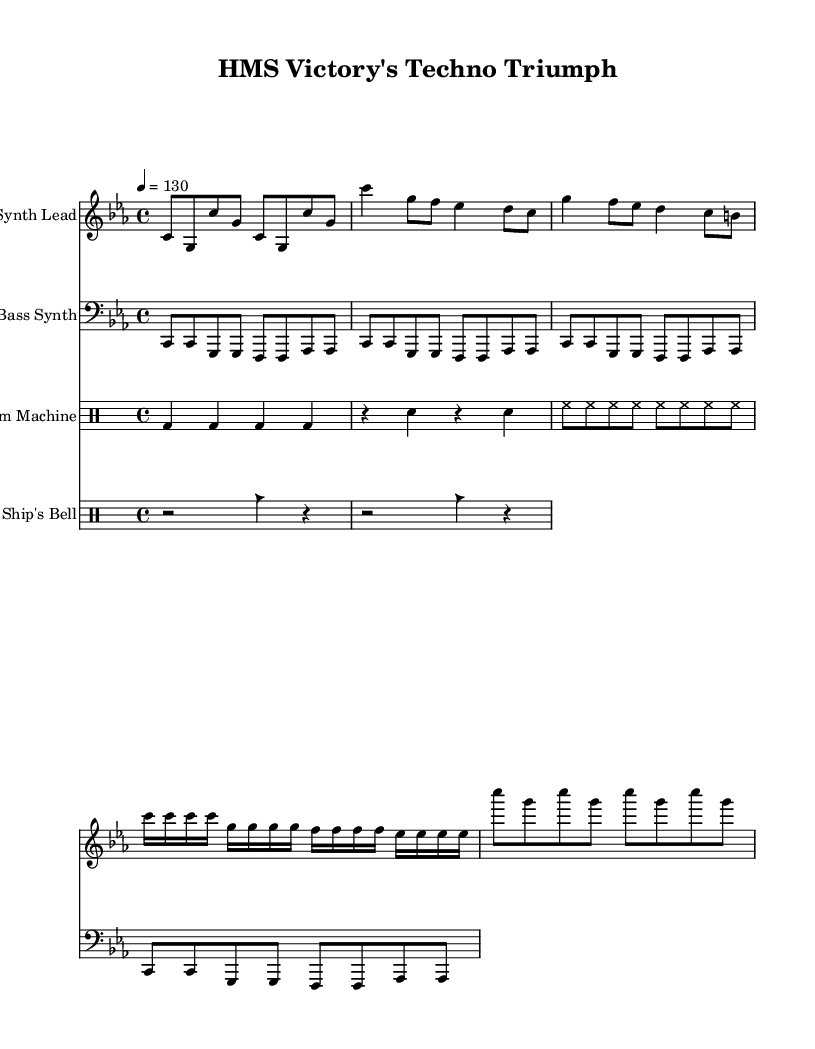What is the key signature of this music? The key signature indicates that the music is in C minor, which has three flats (B flat, E flat, and A flat). This can be visualized by looking at the key signature at the beginning of the staff.
Answer: C minor What is the time signature of the piece? The time signature shown at the beginning of the staff is 4/4, which indicates that there are four beats per measure and the quarter note receives one beat. This can be confirmed by viewing the fraction formed in the time signature area.
Answer: 4/4 What is the tempo marking of the music? The tempo marking stated at the beginning of the score is "4 = 130," meaning the piece should be played at a speed where there are four beats in a measure and the tempo is 130 beats per minute. This tempo is indicated near the top of the score.
Answer: 130 How many measures are designated for the "Synth Lead" instrument? The score for the "Synth Lead" consists of a total of eight measures, which can be counted distinctly within the staff under the instrument's designation. Each complete set of musical notation before the bar lines indicates one measure.
Answer: Eight What is the pattern for the bass synth? The bass synth consists of a repeating pattern that unfolds four times, producing a simple sequence of notes with specific rhythmic division in each measure. By examining the notation underneath the bass staff, this can be verified.
Answer: C, G, F, A flat What type of rhythm is used for the drum machine? The drum machine employs a repetitive and consistent rhythmic pattern featuring kick drums, snares, and hi-hats, designed to establish a driving beat typical of dance music. By analyzing the anticipated placements of different drum sounds in the notation, this can be deduced.
Answer: Four on the floor Identify one distinctive sound instrument used alongside the music. The sheet music features a unique "Ship's Bell" part, which offers a distinct sound that complements the synth sections and adds thematic significance reflecting British naval history, indicated clearly in the notation below the drum staff.
Answer: Ship's Bell 